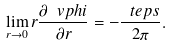<formula> <loc_0><loc_0><loc_500><loc_500>\lim _ { r \rightarrow 0 } r \frac { \partial \ v p h i } { \partial r } = - \frac { \ t e p s } { 2 \pi } .</formula> 